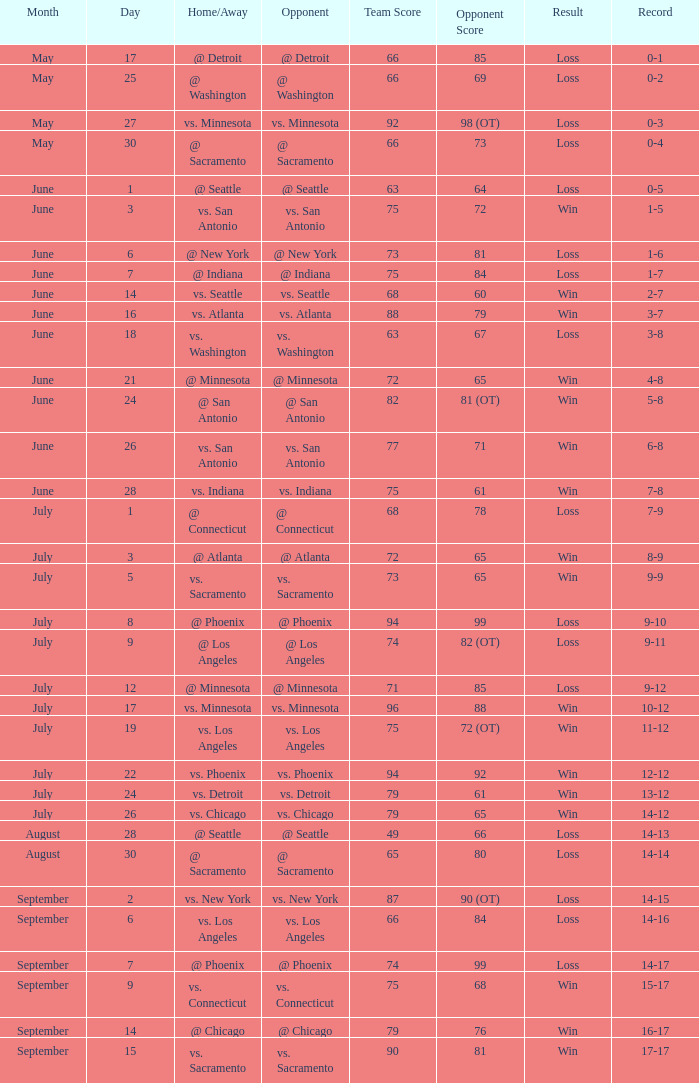On which date did the game with a 7-9 record and a loss occur? July 1. 